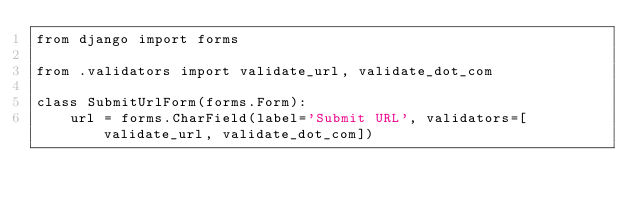<code> <loc_0><loc_0><loc_500><loc_500><_Python_>from django import forms

from .validators import validate_url, validate_dot_com

class SubmitUrlForm(forms.Form):
    url = forms.CharField(label='Submit URL', validators=[validate_url, validate_dot_com])
</code> 